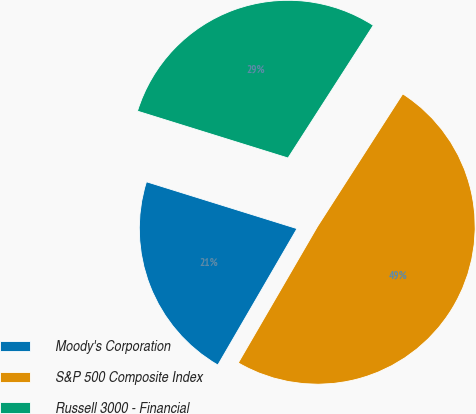Convert chart. <chart><loc_0><loc_0><loc_500><loc_500><pie_chart><fcel>Moody's Corporation<fcel>S&P 500 Composite Index<fcel>Russell 3000 - Financial<nl><fcel>21.43%<fcel>49.28%<fcel>29.29%<nl></chart> 